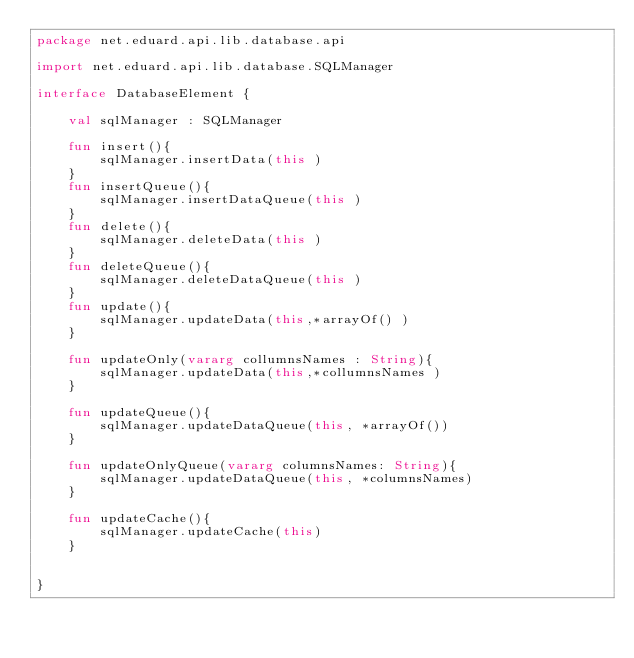<code> <loc_0><loc_0><loc_500><loc_500><_Kotlin_>package net.eduard.api.lib.database.api

import net.eduard.api.lib.database.SQLManager

interface DatabaseElement {

    val sqlManager : SQLManager

    fun insert(){
        sqlManager.insertData(this )
    }
    fun insertQueue(){
        sqlManager.insertDataQueue(this )
    }
    fun delete(){
        sqlManager.deleteData(this )
    }
    fun deleteQueue(){
        sqlManager.deleteDataQueue(this )
    }
    fun update(){
        sqlManager.updateData(this,*arrayOf() )
    }

    fun updateOnly(vararg collumnsNames : String){
        sqlManager.updateData(this,*collumnsNames )
    }

    fun updateQueue(){
        sqlManager.updateDataQueue(this, *arrayOf())
    }

    fun updateOnlyQueue(vararg columnsNames: String){
        sqlManager.updateDataQueue(this, *columnsNames)
    }

    fun updateCache(){
        sqlManager.updateCache(this)
    }


}</code> 